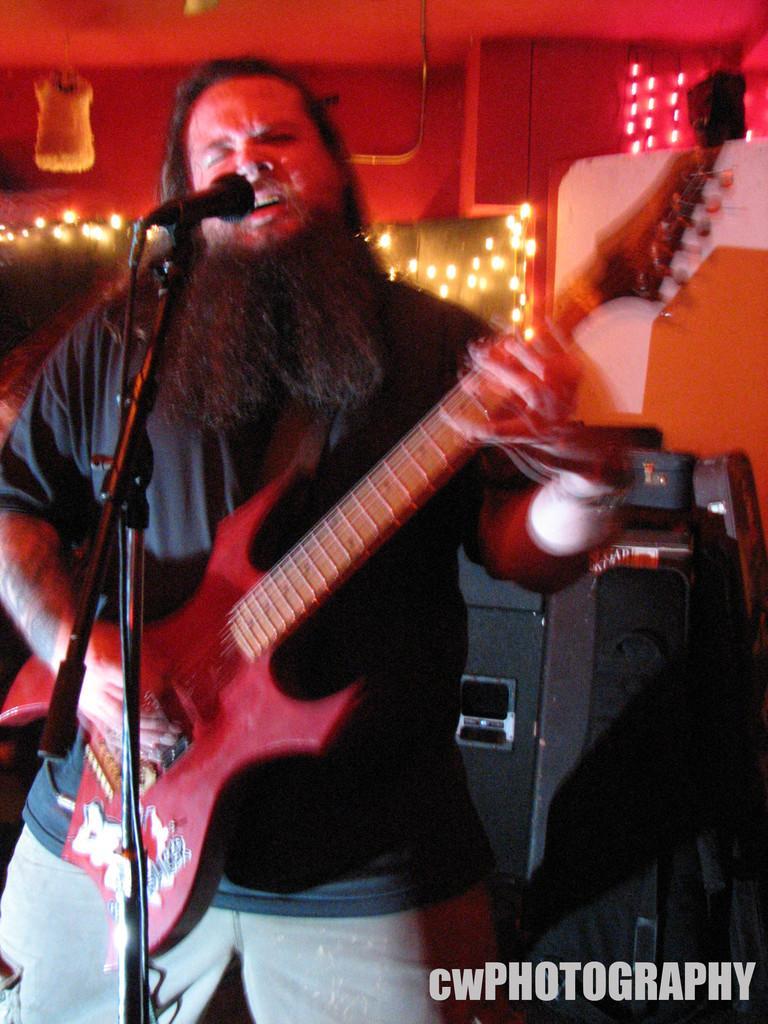How would you summarize this image in a sentence or two? In this image there is a person wearing black color T-shirt playing guitar and there is a microphone in front of him and at the right side of the image there is a sound box. 